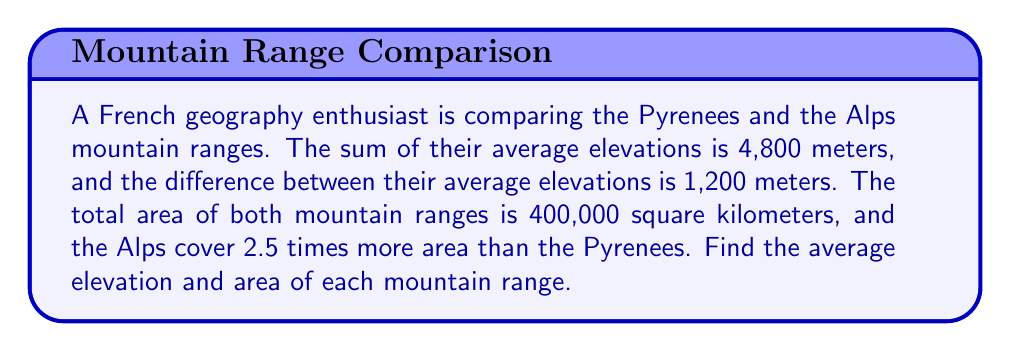Teach me how to tackle this problem. Let's approach this problem step by step using a system of equations:

1. Let $p$ be the average elevation of the Pyrenees and $a$ be the average elevation of the Alps in meters.
2. Let $P$ be the area of the Pyrenees and $A$ be the area of the Alps in square kilometers.

For the elevations:
$$p + a = 4800$$ (sum of elevations)
$$a - p = 1200$$ (difference in elevations)

For the areas:
$$P + A = 400000$$ (total area)
$$A = 2.5P$$ (Alps area is 2.5 times Pyrenees area)

Solving the elevation equations:
$$p + a = 4800$$
$$a - p = 1200$$
Adding these equations:
$$2a = 6000$$
$$a = 3000$$

Substituting back:
$$p + 3000 = 4800$$
$$p = 1800$$

Solving the area equations:
$$P + A = 400000$$
$$P + 2.5P = 400000$$
$$3.5P = 400000$$
$$P = 114285.7$$

Substituting back:
$$A = 2.5P = 2.5 \times 114285.7 = 285714.3$$

Therefore:
- Pyrenees average elevation: 1,800 meters
- Alps average elevation: 3,000 meters
- Pyrenees area: 114,285.7 square kilometers
- Alps area: 285,714.3 square kilometers
Answer: Pyrenees: 1,800 m average elevation, 114,286 km² area
Alps: 3,000 m average elevation, 285,714 km² area 